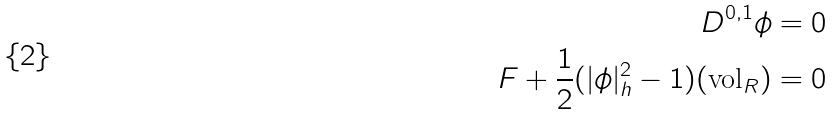<formula> <loc_0><loc_0><loc_500><loc_500>D ^ { 0 , 1 } \phi = 0 \\ F + \frac { 1 } { 2 } ( | \phi | ^ { 2 } _ { h } - 1 ) ( \text {vol} _ { R } ) = 0</formula> 